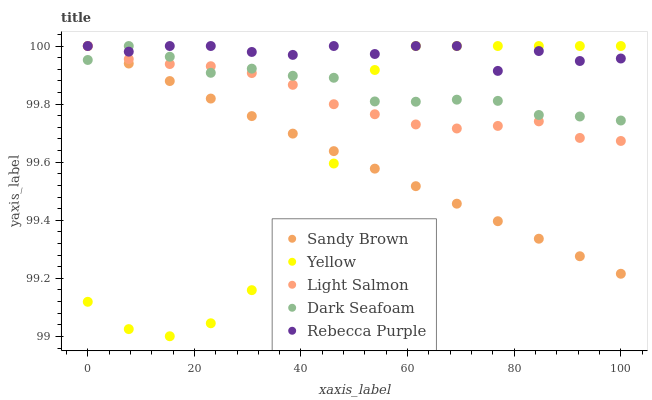Does Yellow have the minimum area under the curve?
Answer yes or no. Yes. Does Rebecca Purple have the maximum area under the curve?
Answer yes or no. Yes. Does Sandy Brown have the minimum area under the curve?
Answer yes or no. No. Does Sandy Brown have the maximum area under the curve?
Answer yes or no. No. Is Sandy Brown the smoothest?
Answer yes or no. Yes. Is Yellow the roughest?
Answer yes or no. Yes. Is Dark Seafoam the smoothest?
Answer yes or no. No. Is Dark Seafoam the roughest?
Answer yes or no. No. Does Yellow have the lowest value?
Answer yes or no. Yes. Does Sandy Brown have the lowest value?
Answer yes or no. No. Does Rebecca Purple have the highest value?
Answer yes or no. Yes. Does Rebecca Purple intersect Dark Seafoam?
Answer yes or no. Yes. Is Rebecca Purple less than Dark Seafoam?
Answer yes or no. No. Is Rebecca Purple greater than Dark Seafoam?
Answer yes or no. No. 